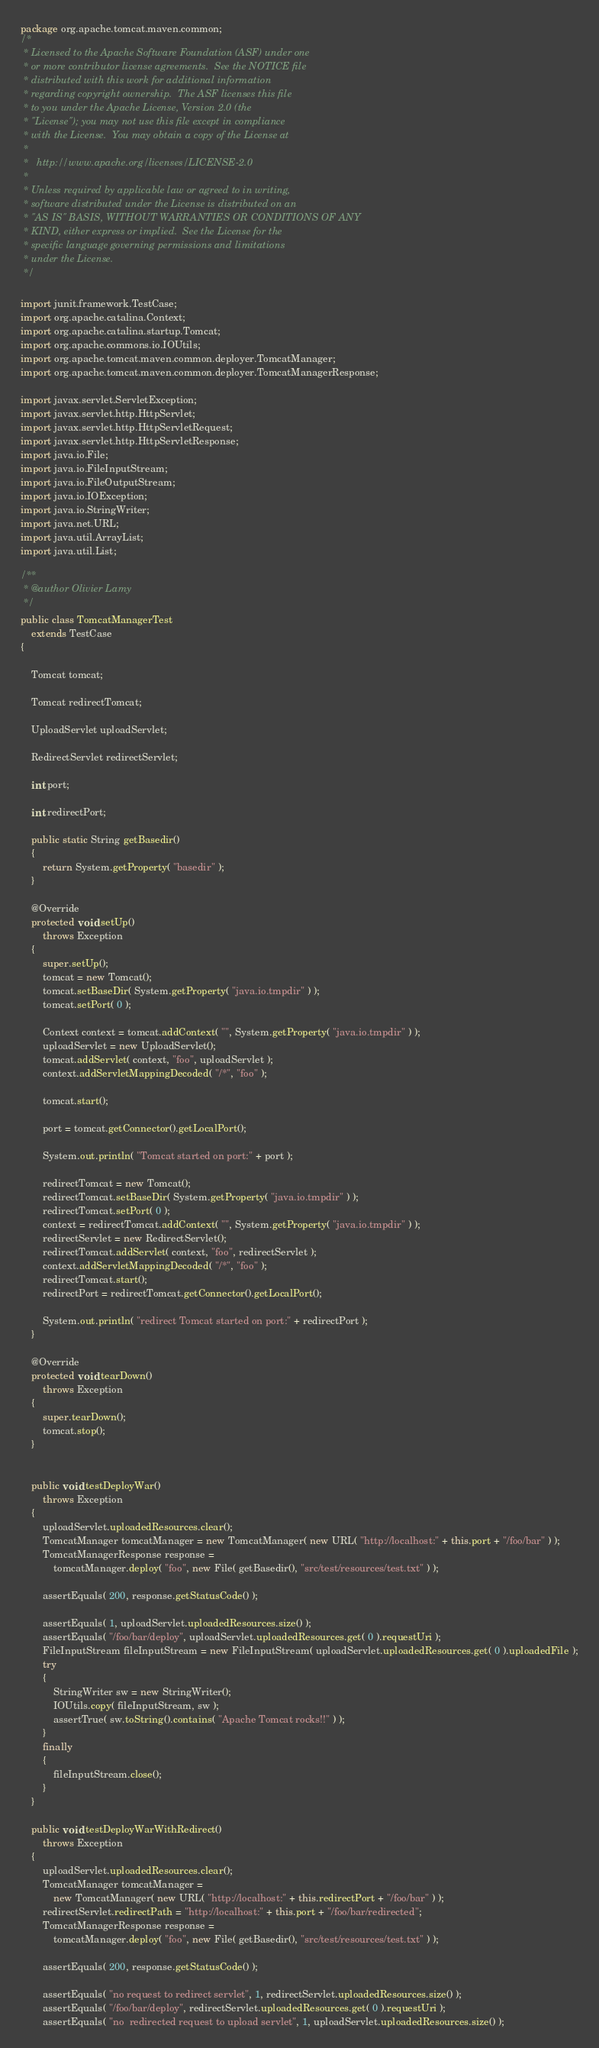<code> <loc_0><loc_0><loc_500><loc_500><_Java_>package org.apache.tomcat.maven.common;
/*
 * Licensed to the Apache Software Foundation (ASF) under one
 * or more contributor license agreements.  See the NOTICE file
 * distributed with this work for additional information
 * regarding copyright ownership.  The ASF licenses this file
 * to you under the Apache License, Version 2.0 (the
 * "License"); you may not use this file except in compliance
 * with the License.  You may obtain a copy of the License at
 *
 *   http://www.apache.org/licenses/LICENSE-2.0
 *
 * Unless required by applicable law or agreed to in writing,
 * software distributed under the License is distributed on an
 * "AS IS" BASIS, WITHOUT WARRANTIES OR CONDITIONS OF ANY
 * KIND, either express or implied.  See the License for the
 * specific language governing permissions and limitations
 * under the License.
 */

import junit.framework.TestCase;
import org.apache.catalina.Context;
import org.apache.catalina.startup.Tomcat;
import org.apache.commons.io.IOUtils;
import org.apache.tomcat.maven.common.deployer.TomcatManager;
import org.apache.tomcat.maven.common.deployer.TomcatManagerResponse;

import javax.servlet.ServletException;
import javax.servlet.http.HttpServlet;
import javax.servlet.http.HttpServletRequest;
import javax.servlet.http.HttpServletResponse;
import java.io.File;
import java.io.FileInputStream;
import java.io.FileOutputStream;
import java.io.IOException;
import java.io.StringWriter;
import java.net.URL;
import java.util.ArrayList;
import java.util.List;

/**
 * @author Olivier Lamy
 */
public class TomcatManagerTest
    extends TestCase
{

    Tomcat tomcat;

    Tomcat redirectTomcat;

    UploadServlet uploadServlet;

    RedirectServlet redirectServlet;

    int port;

    int redirectPort;

    public static String getBasedir()
    {
        return System.getProperty( "basedir" );
    }

    @Override
    protected void setUp()
        throws Exception
    {
        super.setUp();
        tomcat = new Tomcat();
        tomcat.setBaseDir( System.getProperty( "java.io.tmpdir" ) );
        tomcat.setPort( 0 );

        Context context = tomcat.addContext( "", System.getProperty( "java.io.tmpdir" ) );
        uploadServlet = new UploadServlet();
        tomcat.addServlet( context, "foo", uploadServlet );
        context.addServletMappingDecoded( "/*", "foo" );

        tomcat.start();

        port = tomcat.getConnector().getLocalPort();

        System.out.println( "Tomcat started on port:" + port );

        redirectTomcat = new Tomcat();
        redirectTomcat.setBaseDir( System.getProperty( "java.io.tmpdir" ) );
        redirectTomcat.setPort( 0 );
        context = redirectTomcat.addContext( "", System.getProperty( "java.io.tmpdir" ) );
        redirectServlet = new RedirectServlet();
        redirectTomcat.addServlet( context, "foo", redirectServlet );
        context.addServletMappingDecoded( "/*", "foo" );
        redirectTomcat.start();
        redirectPort = redirectTomcat.getConnector().getLocalPort();

        System.out.println( "redirect Tomcat started on port:" + redirectPort );
    }

    @Override
    protected void tearDown()
        throws Exception
    {
        super.tearDown();
        tomcat.stop();
    }


    public void testDeployWar()
        throws Exception
    {
        uploadServlet.uploadedResources.clear();
        TomcatManager tomcatManager = new TomcatManager( new URL( "http://localhost:" + this.port + "/foo/bar" ) );
        TomcatManagerResponse response =
            tomcatManager.deploy( "foo", new File( getBasedir(), "src/test/resources/test.txt" ) );

        assertEquals( 200, response.getStatusCode() );

        assertEquals( 1, uploadServlet.uploadedResources.size() );
        assertEquals( "/foo/bar/deploy", uploadServlet.uploadedResources.get( 0 ).requestUri );
        FileInputStream fileInputStream = new FileInputStream( uploadServlet.uploadedResources.get( 0 ).uploadedFile );
        try
        {
            StringWriter sw = new StringWriter();
            IOUtils.copy( fileInputStream, sw );
            assertTrue( sw.toString().contains( "Apache Tomcat rocks!!" ) );
        }
        finally
        {
            fileInputStream.close();
        }
    }

    public void testDeployWarWithRedirect()
        throws Exception
    {
        uploadServlet.uploadedResources.clear();
        TomcatManager tomcatManager =
            new TomcatManager( new URL( "http://localhost:" + this.redirectPort + "/foo/bar" ) );
        redirectServlet.redirectPath = "http://localhost:" + this.port + "/foo/bar/redirected";
        TomcatManagerResponse response =
            tomcatManager.deploy( "foo", new File( getBasedir(), "src/test/resources/test.txt" ) );

        assertEquals( 200, response.getStatusCode() );

        assertEquals( "no request to redirect servlet", 1, redirectServlet.uploadedResources.size() );
        assertEquals( "/foo/bar/deploy", redirectServlet.uploadedResources.get( 0 ).requestUri );
        assertEquals( "no  redirected request to upload servlet", 1, uploadServlet.uploadedResources.size() );
</code> 